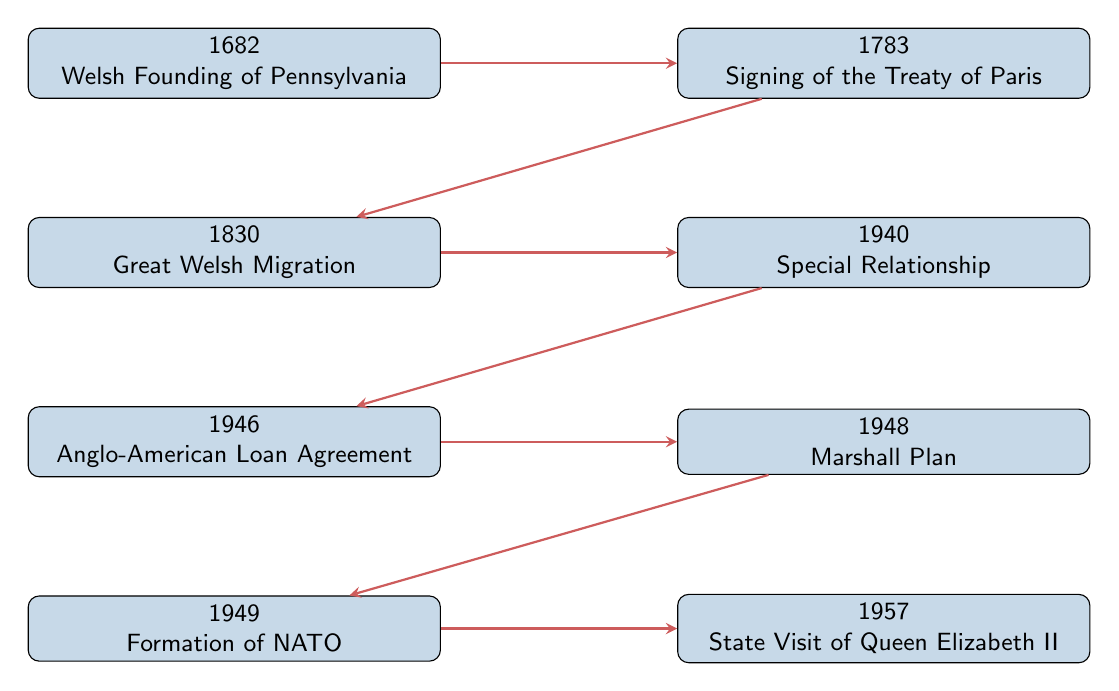What is the first event listed in the timeline? The first event in the timeline is found at the top node labeled "1682" which describes the Welsh Founding of Pennsylvania.
Answer: Welsh Founding of Pennsylvania What year did the Special Relationship begin? By checking the node labeled "1940", we find that this event is marked as taking place in the year 1940.
Answer: 1940 Which event occurred immediately after the Signing of the Treaty of Paris? The flow from the Signing of the Treaty of Paris node points to the node below it, which is the Great Welsh Migration.
Answer: Great Welsh Migration How many events are linked to the Anglo-American Loan Agreement? Starting from the Anglo-American Loan Agreement node at "1946", it has two outgoing arrows, leading to the Marshall Plan and the Formation of NATO events.
Answer: 2 What is the last event in the diagram? The last node in the timeline is "1957" and it describes the State Visit of Queen Elizabeth II, which is positioned at the far right end of the flow.
Answer: State Visit of Queen Elizabeth II Which event connects the years 1830 and 1940? Reviewing the nodes, it is clear that the Great Welsh Migration of 1830 connects to the Special Relationship event in 1940 through the arrow in between them.
Answer: Great Welsh Migration What is the relationship between the Signing of the Treaty of Paris and the Great Welsh Migration? The Signing of the Treaty of Paris node is directly above the Great Welsh Migration node, with an arrow indicating a flowing sequence in the timeline.
Answer: Sequential How many years are between the Marshall Plan and the State Visit of Queen Elizabeth II? The Marshall Plan is in 1948 and the State Visit of Queen Elizabeth II is in 1957. Calculating the difference, 1957 - 1948 equals 9 years.
Answer: 9 years In which year was the Formation of NATO established? Referring to the node positioned just after the Marshall Plan, the Formation of NATO event is marked as taking place in 1949.
Answer: 1949 